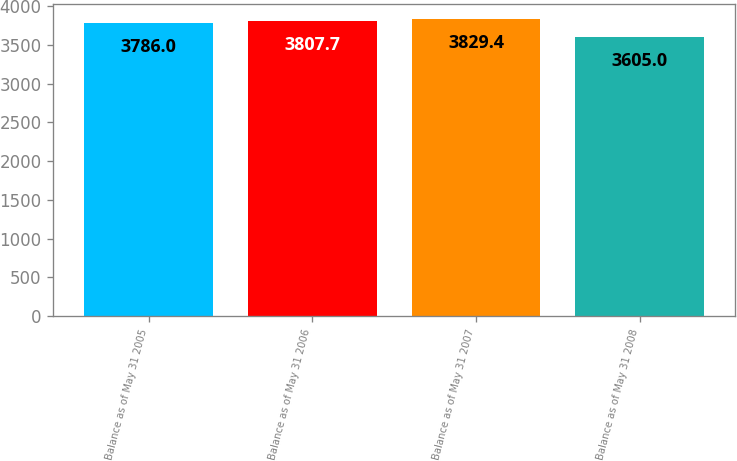Convert chart to OTSL. <chart><loc_0><loc_0><loc_500><loc_500><bar_chart><fcel>Balance as of May 31 2005<fcel>Balance as of May 31 2006<fcel>Balance as of May 31 2007<fcel>Balance as of May 31 2008<nl><fcel>3786<fcel>3807.7<fcel>3829.4<fcel>3605<nl></chart> 